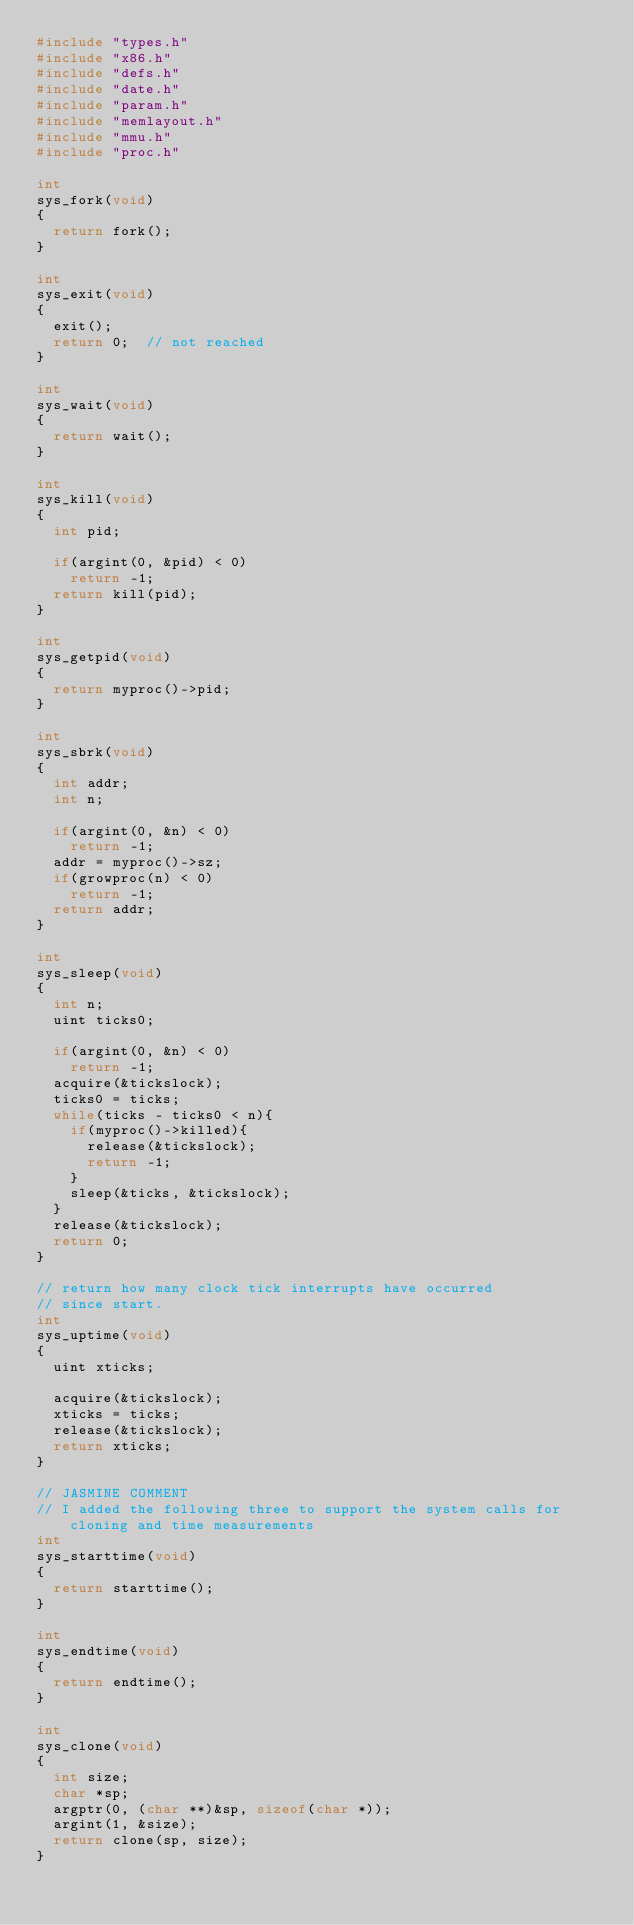Convert code to text. <code><loc_0><loc_0><loc_500><loc_500><_C_>#include "types.h"
#include "x86.h"
#include "defs.h"
#include "date.h"
#include "param.h"
#include "memlayout.h"
#include "mmu.h"
#include "proc.h"

int
sys_fork(void)
{
  return fork();
}

int
sys_exit(void)
{
  exit();
  return 0;  // not reached
}

int
sys_wait(void)
{
  return wait();
}

int
sys_kill(void)
{
  int pid;

  if(argint(0, &pid) < 0)
    return -1;
  return kill(pid);
}

int
sys_getpid(void)
{
  return myproc()->pid;
}

int
sys_sbrk(void)
{
  int addr;
  int n;

  if(argint(0, &n) < 0)
    return -1;
  addr = myproc()->sz;
  if(growproc(n) < 0)
    return -1;
  return addr;
}

int
sys_sleep(void)
{
  int n;
  uint ticks0;

  if(argint(0, &n) < 0)
    return -1;
  acquire(&tickslock);
  ticks0 = ticks;
  while(ticks - ticks0 < n){
    if(myproc()->killed){
      release(&tickslock);
      return -1;
    }
    sleep(&ticks, &tickslock);
  }
  release(&tickslock);
  return 0;
}

// return how many clock tick interrupts have occurred
// since start.
int
sys_uptime(void)
{
  uint xticks;

  acquire(&tickslock);
  xticks = ticks;
  release(&tickslock);
  return xticks;
}

// JASMINE COMMENT
// I added the following three to support the system calls for cloning and time measurements
int
sys_starttime(void)
{
  return starttime();
}

int
sys_endtime(void)
{
  return endtime();
}

int
sys_clone(void)
{
  int size;
  char *sp;
  argptr(0, (char **)&sp, sizeof(char *));  
  argint(1, &size);
  return clone(sp, size);
}
</code> 